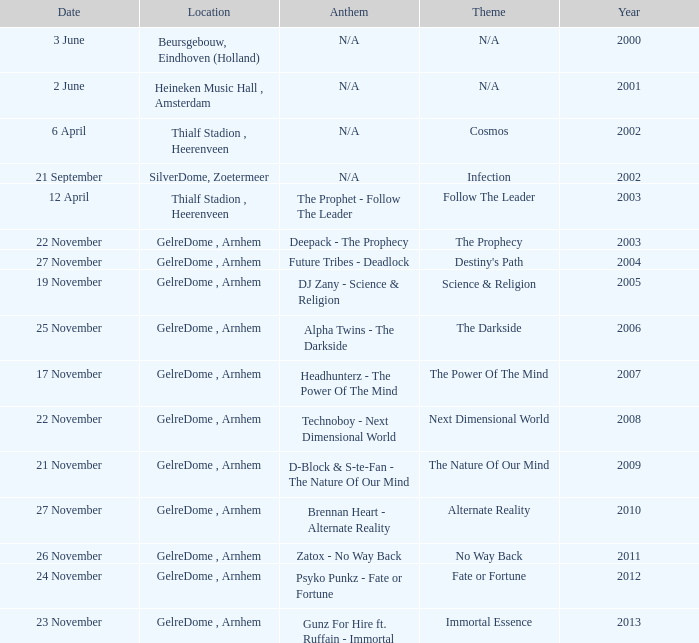What is the earliest year it was located in gelredome, arnhem, and a Anthem of technoboy - next dimensional world? 2008.0. 